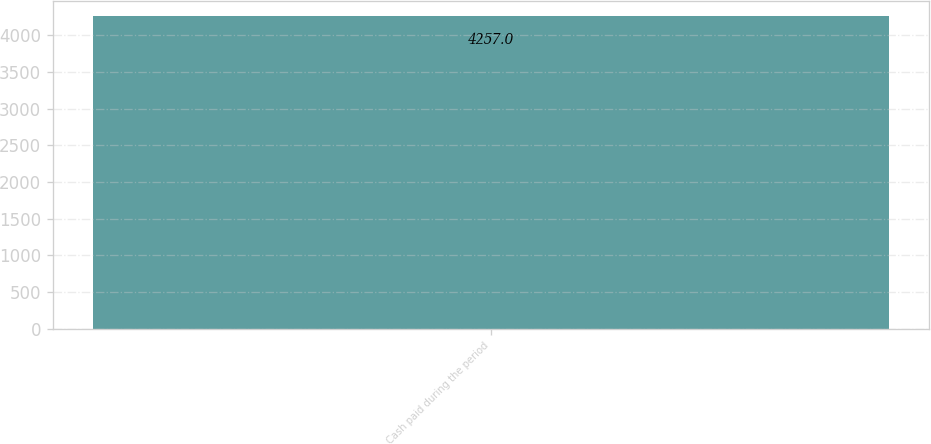<chart> <loc_0><loc_0><loc_500><loc_500><bar_chart><fcel>Cash paid during the period<nl><fcel>4257<nl></chart> 